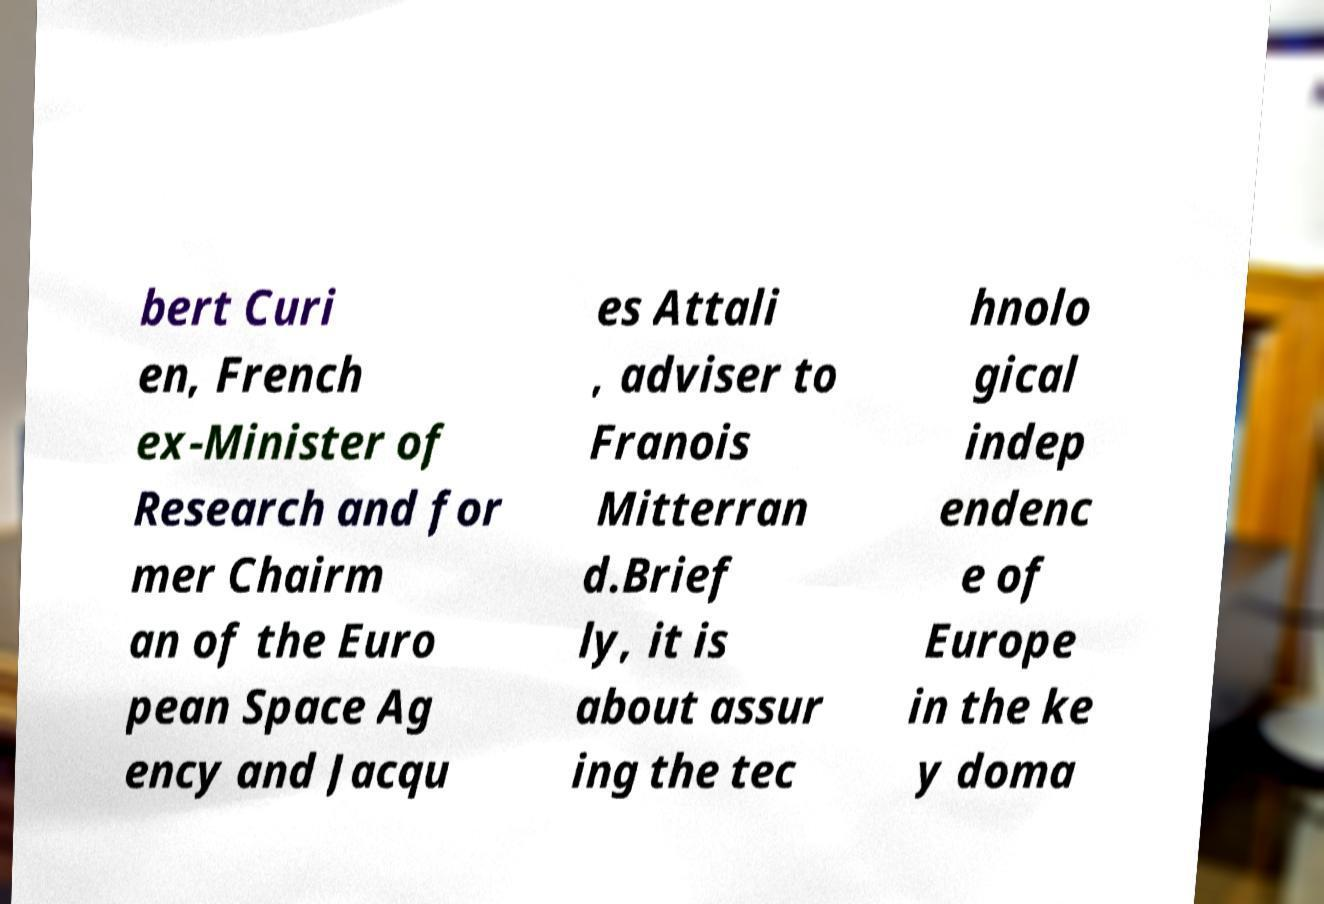I need the written content from this picture converted into text. Can you do that? bert Curi en, French ex-Minister of Research and for mer Chairm an of the Euro pean Space Ag ency and Jacqu es Attali , adviser to Franois Mitterran d.Brief ly, it is about assur ing the tec hnolo gical indep endenc e of Europe in the ke y doma 